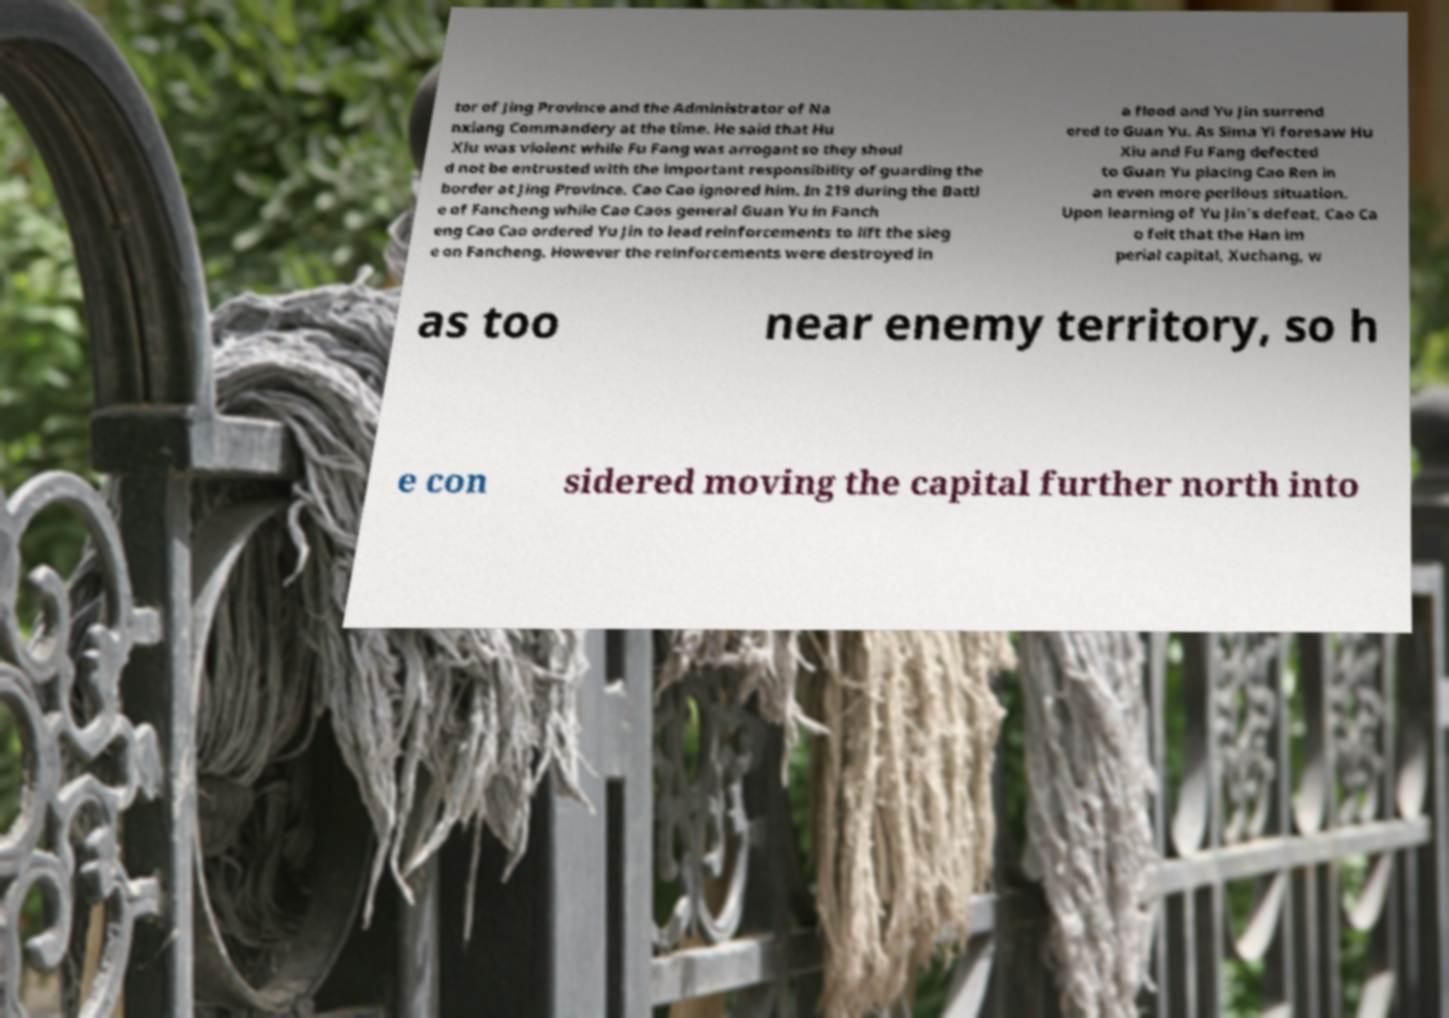What messages or text are displayed in this image? I need them in a readable, typed format. tor of Jing Province and the Administrator of Na nxiang Commandery at the time. He said that Hu Xiu was violent while Fu Fang was arrogant so they shoul d not be entrusted with the important responsibility of guarding the border at Jing Province. Cao Cao ignored him. In 219 during the Battl e of Fancheng while Cao Caos general Guan Yu in Fanch eng Cao Cao ordered Yu Jin to lead reinforcements to lift the sieg e on Fancheng. However the reinforcements were destroyed in a flood and Yu Jin surrend ered to Guan Yu. As Sima Yi foresaw Hu Xiu and Fu Fang defected to Guan Yu placing Cao Ren in an even more perilous situation. Upon learning of Yu Jin's defeat, Cao Ca o felt that the Han im perial capital, Xuchang, w as too near enemy territory, so h e con sidered moving the capital further north into 